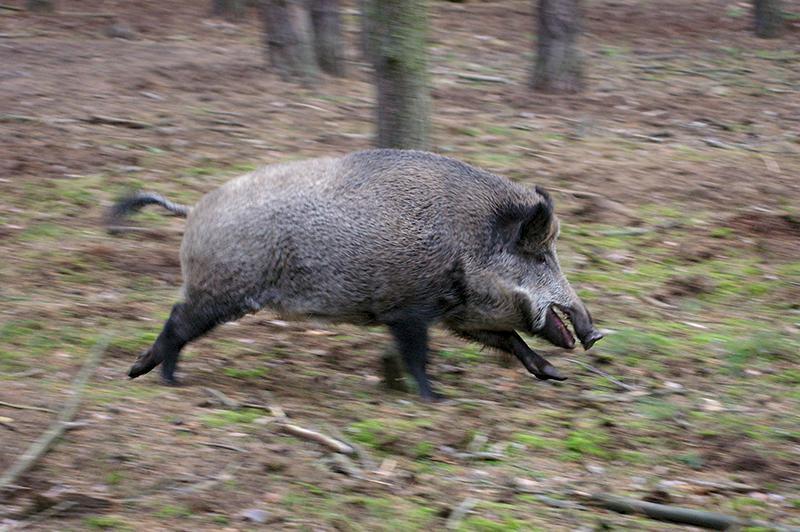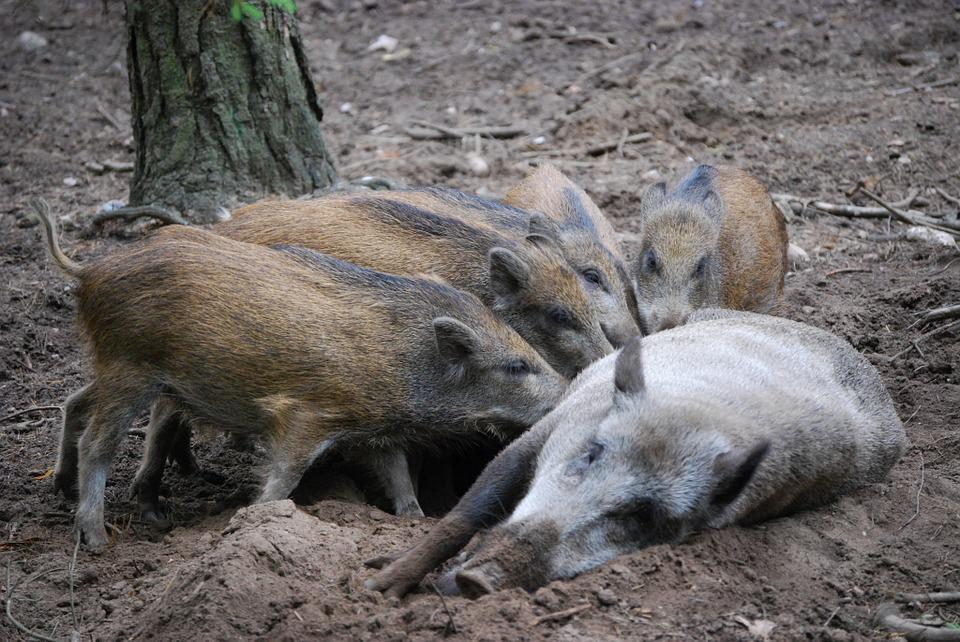The first image is the image on the left, the second image is the image on the right. Considering the images on both sides, is "A wild boar is lying on the ground in the image on the right." valid? Answer yes or no. Yes. The first image is the image on the left, the second image is the image on the right. Examine the images to the left and right. Is the description "The combined images contain only standing pigs, including at least three lighter-colored piglets and at least three bigger adult pigs." accurate? Answer yes or no. No. 